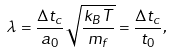Convert formula to latex. <formula><loc_0><loc_0><loc_500><loc_500>\lambda = \frac { \Delta t _ { c } } { a _ { 0 } } \sqrt { \frac { k _ { B } T } { m _ { f } } } = \frac { \Delta t _ { c } } { t _ { 0 } } ,</formula> 